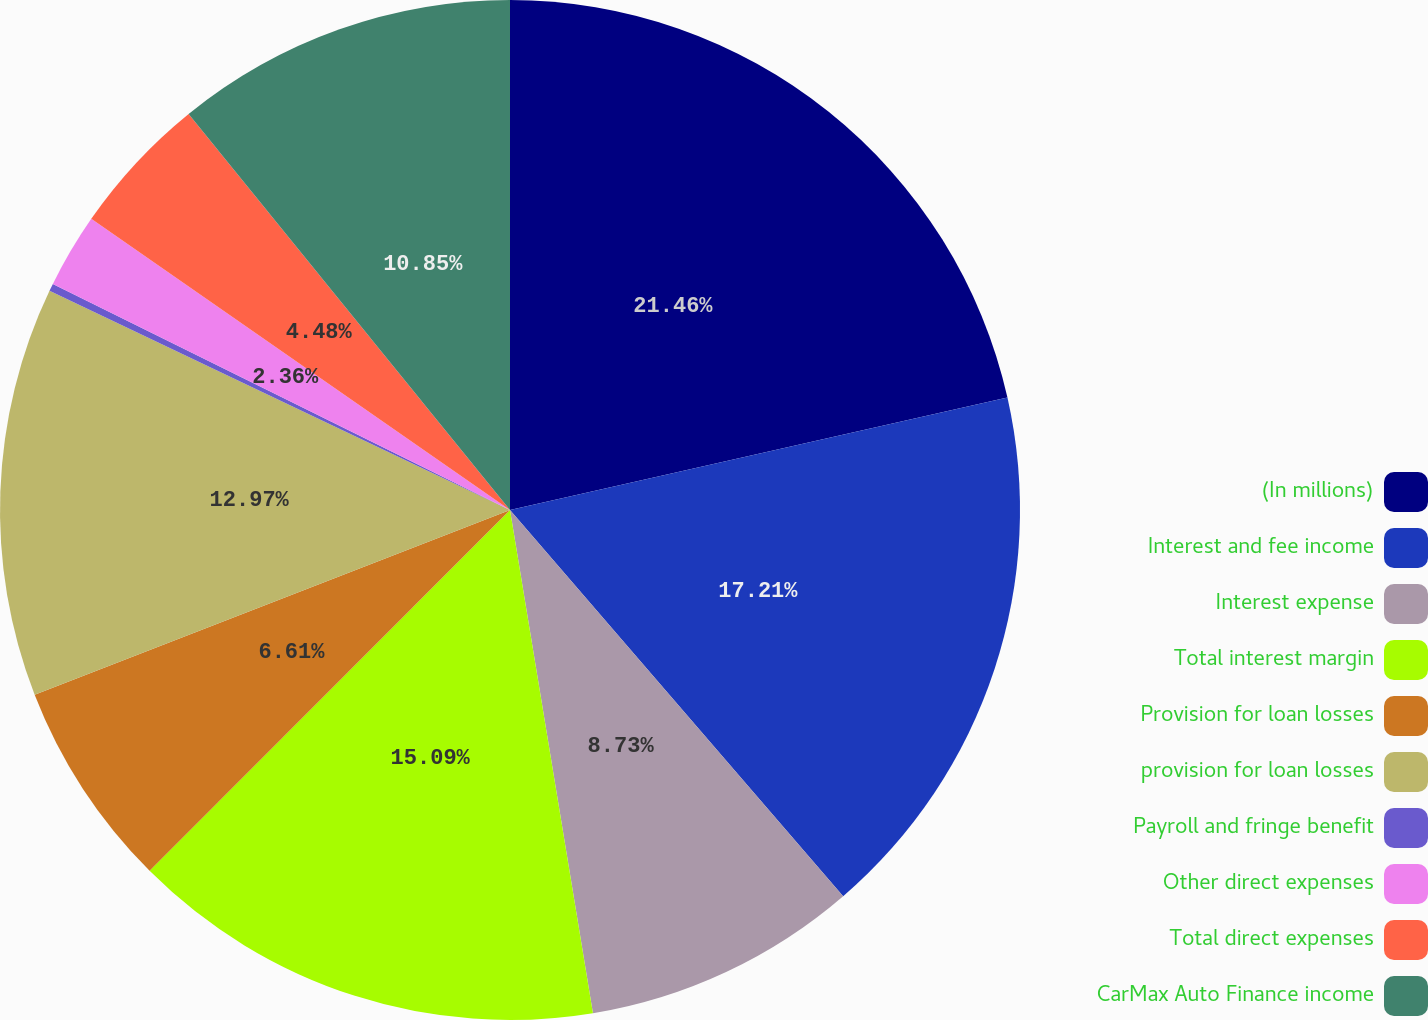Convert chart to OTSL. <chart><loc_0><loc_0><loc_500><loc_500><pie_chart><fcel>(In millions)<fcel>Interest and fee income<fcel>Interest expense<fcel>Total interest margin<fcel>Provision for loan losses<fcel>provision for loan losses<fcel>Payroll and fringe benefit<fcel>Other direct expenses<fcel>Total direct expenses<fcel>CarMax Auto Finance income<nl><fcel>21.46%<fcel>17.21%<fcel>8.73%<fcel>15.09%<fcel>6.61%<fcel>12.97%<fcel>0.24%<fcel>2.36%<fcel>4.48%<fcel>10.85%<nl></chart> 